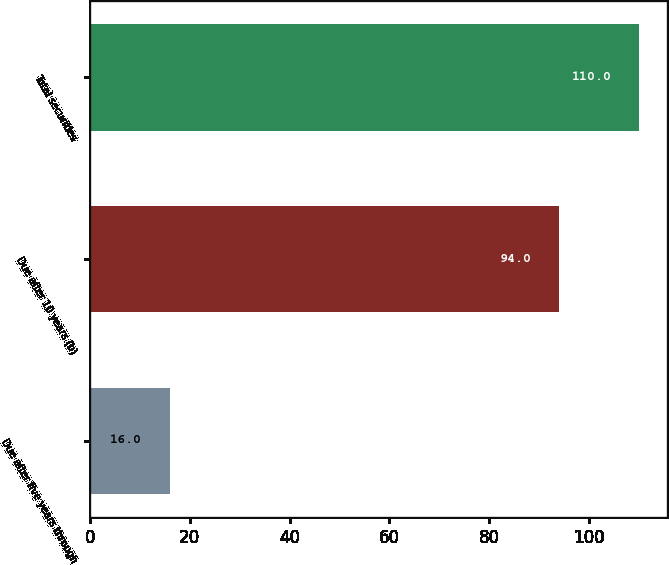Convert chart to OTSL. <chart><loc_0><loc_0><loc_500><loc_500><bar_chart><fcel>Due after five years through<fcel>Due after 10 years (b)<fcel>Total securities<nl><fcel>16<fcel>94<fcel>110<nl></chart> 